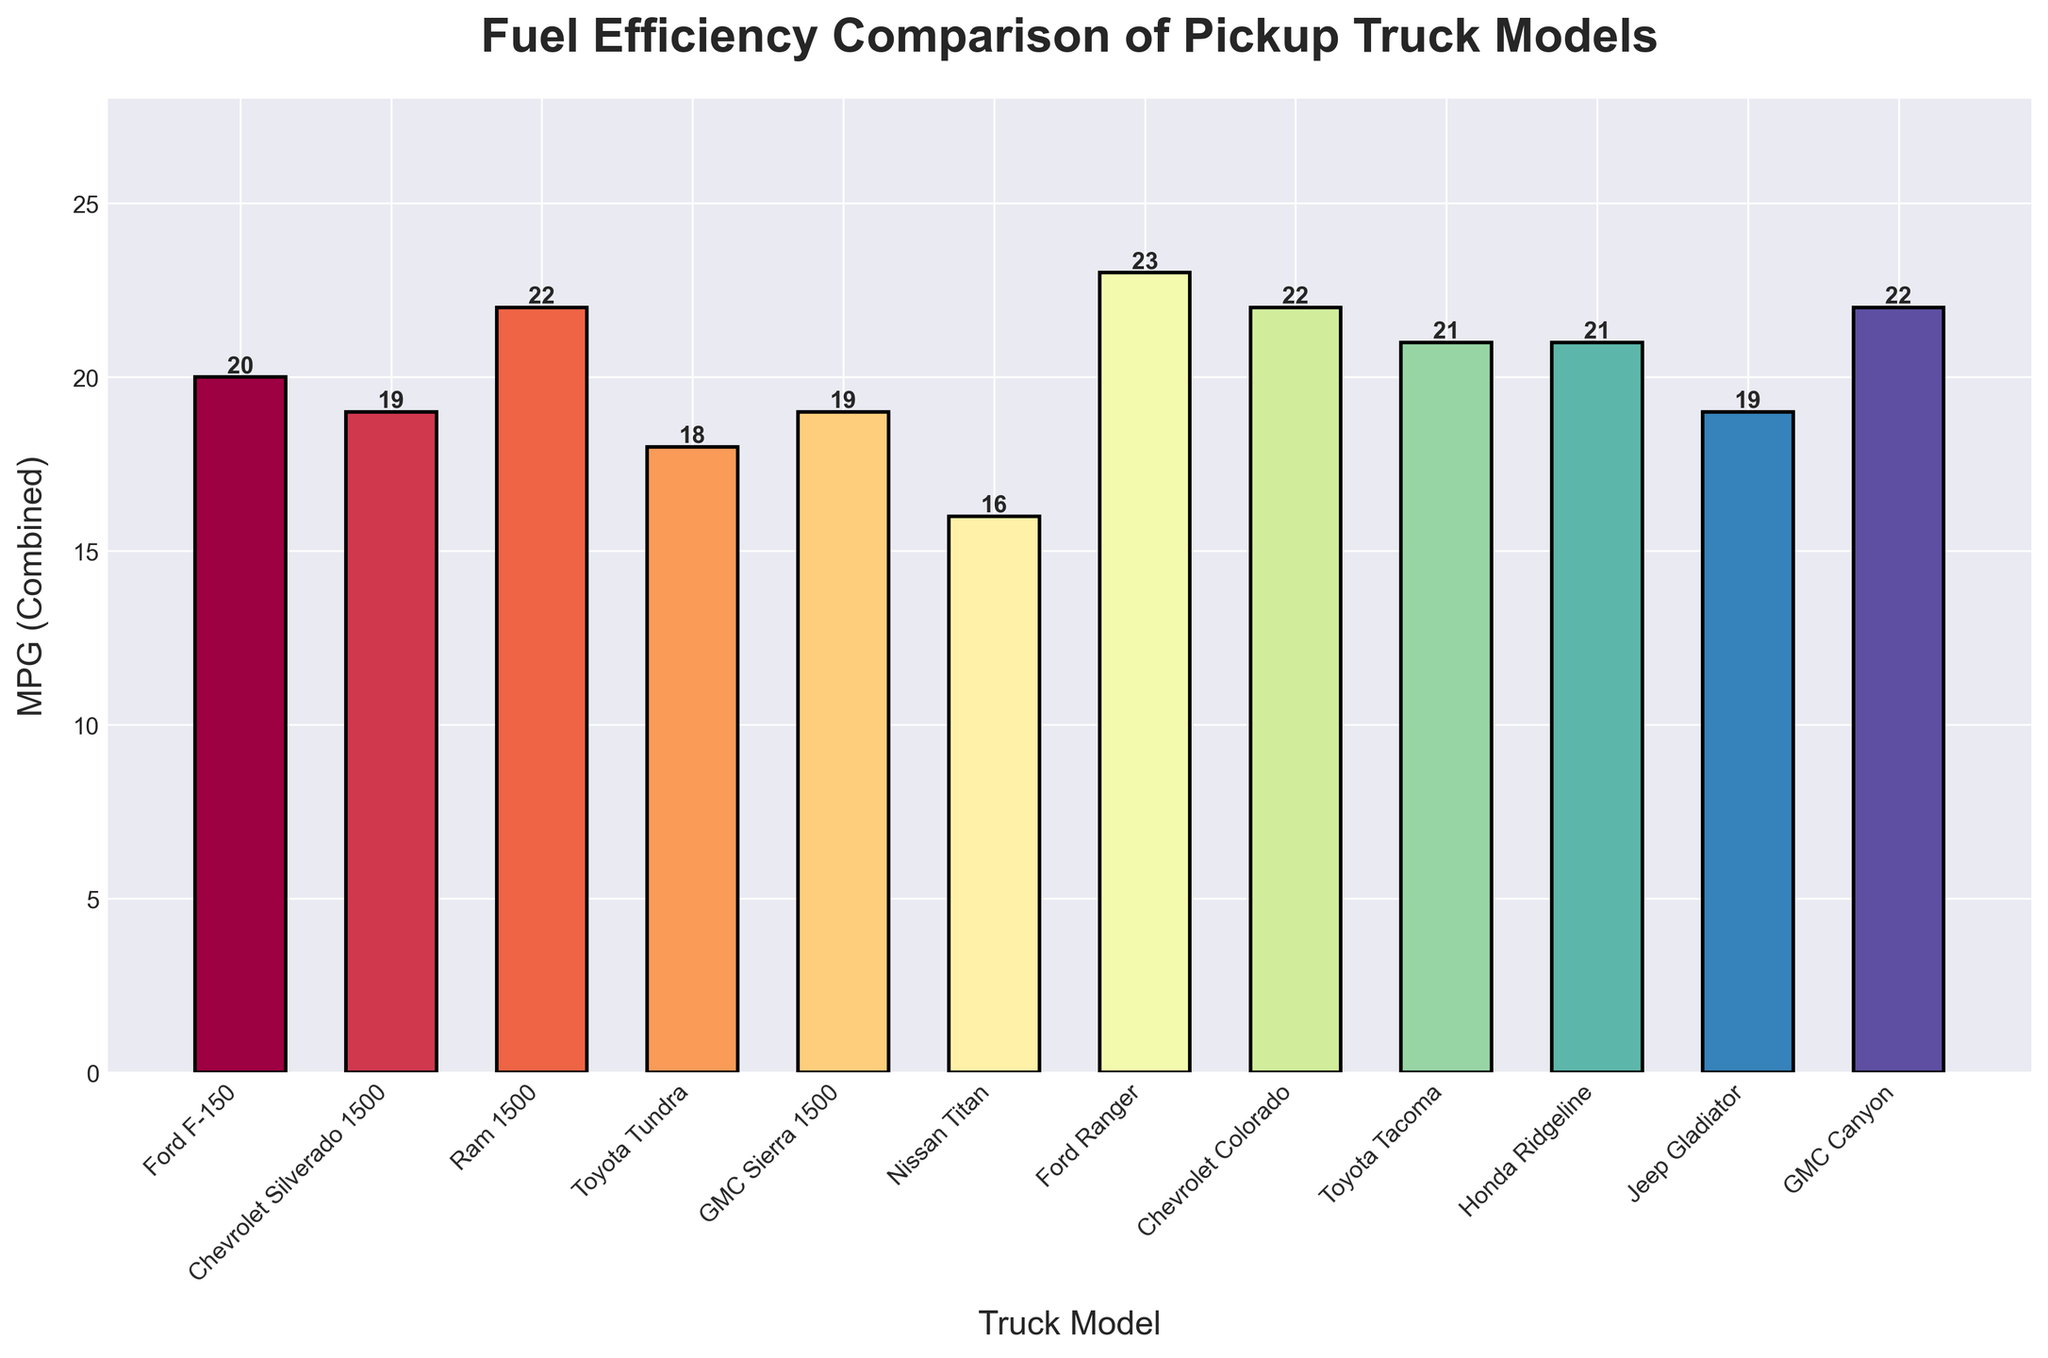Which model has the highest fuel efficiency? The model with the highest fuel efficiency has the tallest bar. Ford Ranger has the tallest bar with an MPG (Combined) of 23.
Answer: Ford Ranger Which model has the lowest fuel efficiency? The model with the lowest fuel efficiency has the shortest bar. Nissan Titan has the shortest bar with an MPG (Combined) of 16.
Answer: Nissan Titan How many models have an MPG (Combined) greater than 20? Count the bars with heights greater than 20. There are 5 models higher than 20: Ram 1500, Ford Ranger, Chevrolet Colorado, Toyota Tacoma, and Honda Ridgeline.
Answer: 5 What is the average MPG (Combined) of the top three models? Identify the top three models: Ford Ranger (23), Ram 1500 (22), and Chevrolet Colorado (22). The average is (23 + 22 + 22) / 3 = 22.33.
Answer: 22.33 Which models have an MPG (Combined) equal to 19? Identify the bars with a height of 19. Chevrolet Silverado 1500, GMC Sierra 1500, and Jeep Gladiator each have an MPG (Combined) of 19.
Answer: Chevrolet Silverado 1500, GMC Sierra 1500, Jeep Gladiator By how much is Ford Ranger more fuel-efficient than the Toyota Tundra? Subtract the Toyota Tundra's MPG (Combined) from the Ford Ranger's MPG (Combined). Ford Ranger is 23 and Toyota Tundra is 18. 23 - 18 = 5.
Answer: 5 Which models have the same fuel efficiency, and what is that MPG value? Identify bars of the same height. Chevrolet Silverado 1500, GMC Sierra 1500, and Jeep Gladiator each have an MPG value of 19. Toyota Tacoma and Honda Ridgeline each have an MPG value of 21.
Answer: 19 (Chevrolet Silverado 1500, GMC Sierra 1500, Jeep Gladiator) and 21 (Toyota Tacoma, Honda Ridgeline) What is the second-lowest MPG (Combined) value and which models have it? Order the MPG values and identify the second-lowest: 16 (Nissan Titan), 18 (Toyota Tundra). Toyota Tundra has the second-lowest MPG value of 18.
Answer: 18 (Toyota Tundra) How many models have an MPG (Combined) between 17 and 21 inclusive? Count the bars with heights (MPG) between 17 and 21 inclusive. The count includes Toyota Tundra, Chevrolet Silverado 1500, GMC Sierra 1500, Jeep Gladiator, Toyota Tacoma, and Honda Ridgeline.
Answer: 6 